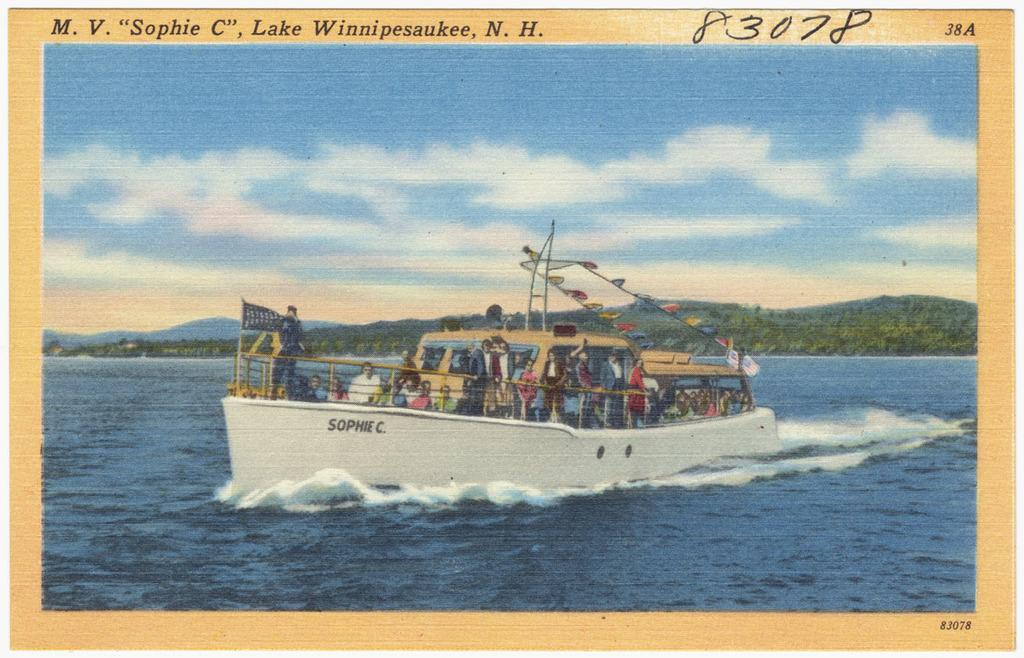<image>
Create a compact narrative representing the image presented. A postcard features a boat called the "Sophie C." 